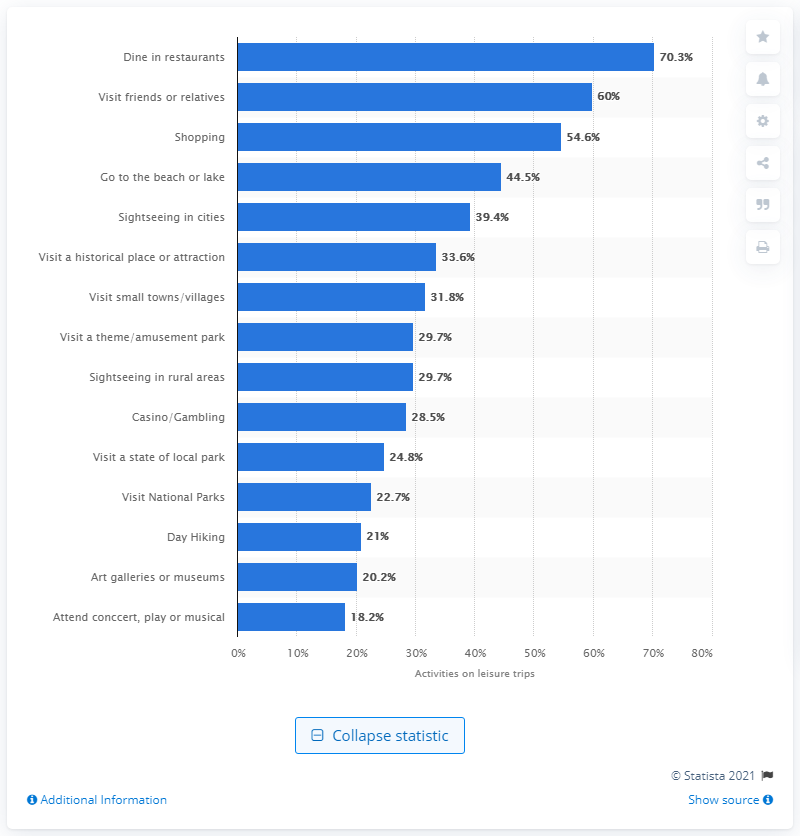What percentage of leisure trip travellers had done dining in a restaurant? According to the data shown in the image, dining in restaurants is a popular activity for leisure trip travelers, with 70.3% partaking in this experience. 